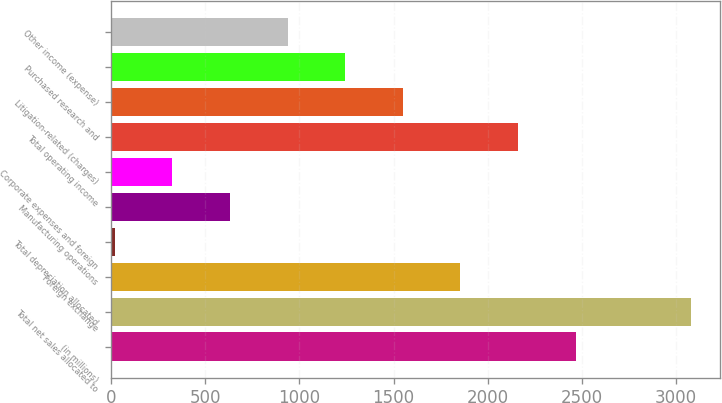Convert chart to OTSL. <chart><loc_0><loc_0><loc_500><loc_500><bar_chart><fcel>(in millions)<fcel>Total net sales allocated to<fcel>Foreign exchange<fcel>Total depreciation allocated<fcel>Manufacturing operations<fcel>Corporate expenses and foreign<fcel>Total operating income<fcel>Litigation-related (charges)<fcel>Purchased research and<fcel>Other income (expense)<nl><fcel>2467<fcel>3079<fcel>1855<fcel>19<fcel>631<fcel>325<fcel>2161<fcel>1549<fcel>1243<fcel>937<nl></chart> 